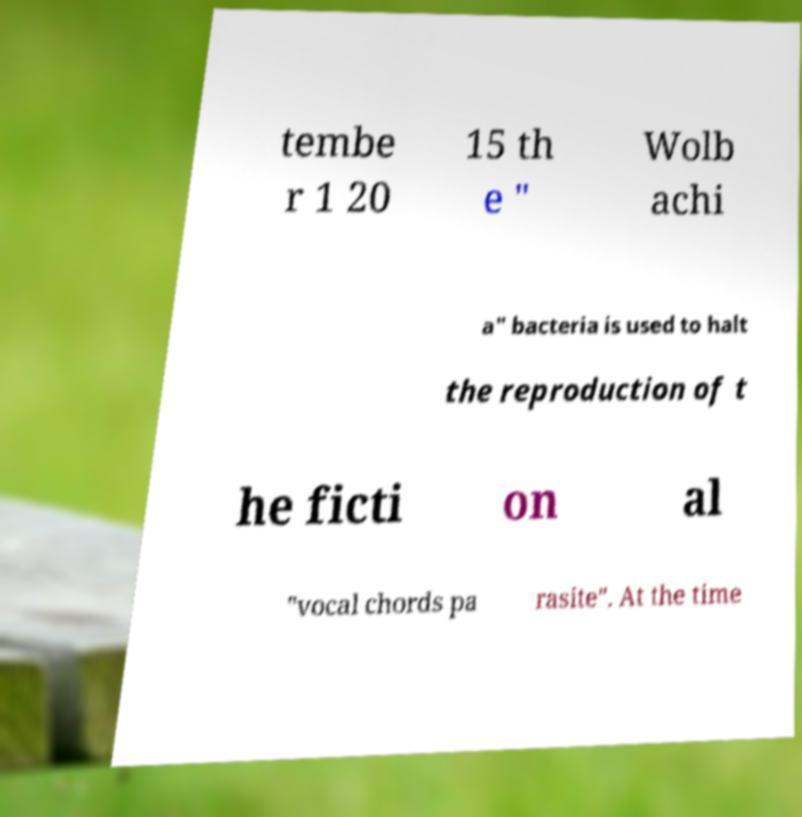There's text embedded in this image that I need extracted. Can you transcribe it verbatim? tembe r 1 20 15 th e " Wolb achi a" bacteria is used to halt the reproduction of t he ficti on al "vocal chords pa rasite". At the time 